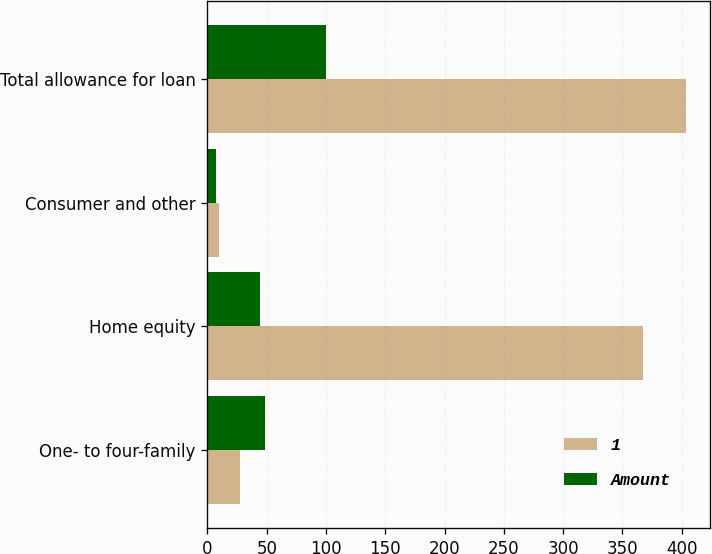<chart> <loc_0><loc_0><loc_500><loc_500><stacked_bar_chart><ecel><fcel>One- to four-family<fcel>Home equity<fcel>Consumer and other<fcel>Total allowance for loan<nl><fcel>1<fcel>27<fcel>367<fcel>10<fcel>404<nl><fcel>Amount<fcel>48.2<fcel>44.6<fcel>7.2<fcel>100<nl></chart> 